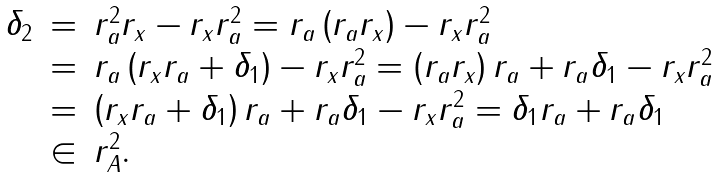<formula> <loc_0><loc_0><loc_500><loc_500>\begin{array} { l l l } \delta _ { 2 } & = & r _ { a } ^ { 2 } r _ { x } - r _ { x } r _ { a } ^ { 2 } = r _ { a } \left ( r _ { a } r _ { x } \right ) - r _ { x } r _ { a } ^ { 2 } \\ & = & r _ { a } \left ( r _ { x } r _ { a } + \delta _ { 1 } \right ) - r _ { x } r _ { a } ^ { 2 } = \left ( r _ { a } r _ { x } \right ) r _ { a } + r _ { a } \delta _ { 1 } - r _ { x } r _ { a } ^ { 2 } \\ & = & \left ( r _ { x } r _ { a } + \delta _ { 1 } \right ) r _ { a } + r _ { a } \delta _ { 1 } - r _ { x } r _ { a } ^ { 2 } = \delta _ { 1 } r _ { a } + r _ { a } \delta _ { 1 } \\ & \in & r _ { A } ^ { 2 } . \end{array}</formula> 